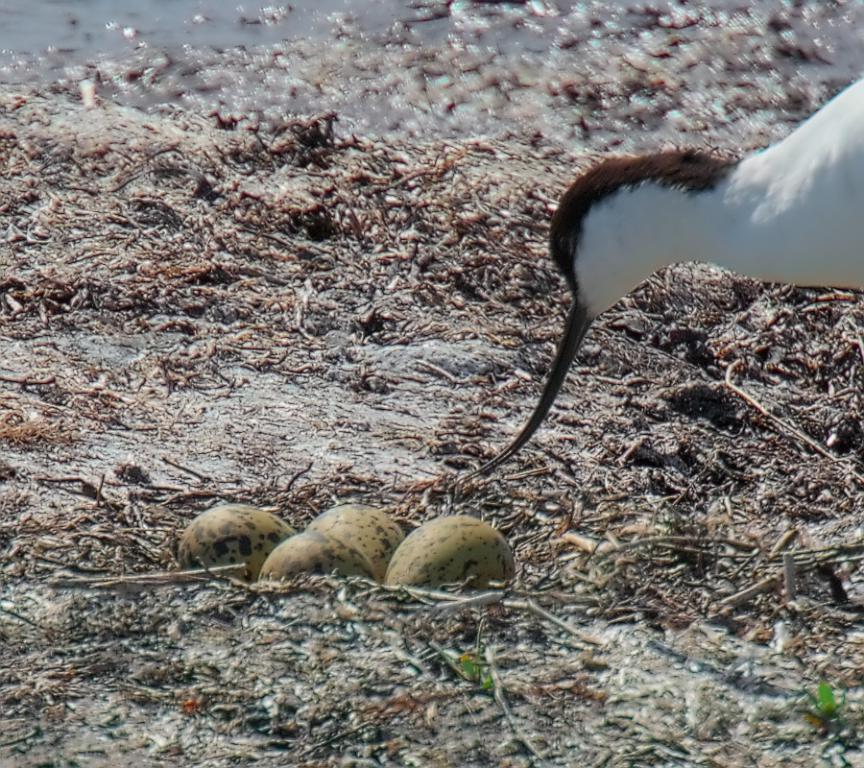How would you summarize this image in a sentence or two? In this image we can see some eggs in a nest and a duck on the ground. We can also see some dried stems and the water. 